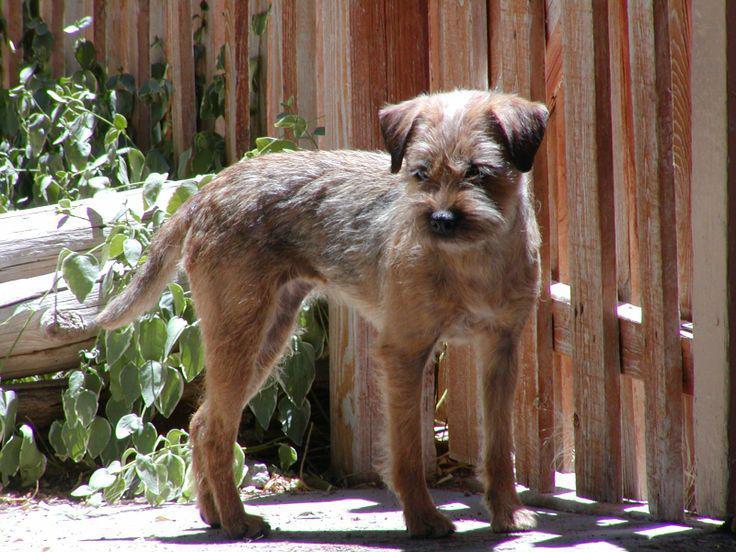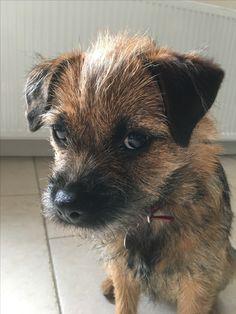The first image is the image on the left, the second image is the image on the right. For the images shown, is this caption "In the image to the right, there is but one dog." true? Answer yes or no. Yes. 